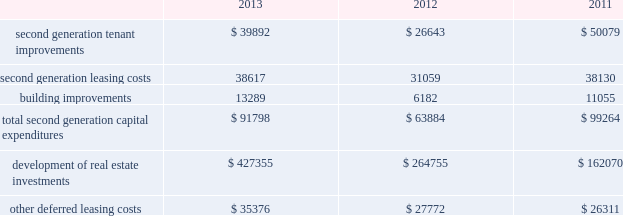36 duke realty corporation annual report 2013 leasing/capital costs tenant improvements and lease-related costs pertaining to our initial leasing of newly completed space , or vacant space in acquired properties , are referred to as first generation expenditures .
Such first generation expenditures for tenant improvements are included within "development of real estate investments" in our consolidated statements of cash flows , while such expenditures for lease-related costs are included within "other deferred leasing costs." cash expenditures related to the construction of a building's shell , as well as the associated site improvements , are also included within "development of real estate investments" in our consolidated statements of cash flows .
Tenant improvements and leasing costs to re-let rental space that we previously leased to tenants are referred to as second generation expenditures .
Building improvements that are not specific to any tenant but serve to improve integral components of our real estate properties are also second generation expenditures .
One of our principal uses of our liquidity is to fund the second generation leasing/capital expenditures of our real estate investments .
The table summarizes our second generation capital expenditures by type of expenditure ( in thousands ) : .
Second generation tenant improvements and leasing costs increased due to a shift in industrial leasing volume from renewal leases to second generation leases ( see data in the key performance indicators section of management's discussion and analysis of financial condition and results of operations ) , which are generally more capital intensive .
Additionally , although the overall renewal volume was lower , renewals for office leases , which are generally more capital intensive than industrial leases , increased from 2012 .
During 2013 , we increased our investment across all product types in non-tenant specific building improvements .
The increase in capital expenditures for the development of real estate investments was the result of our increased focus on wholly owned development projects .
We had wholly owned properties under development with an expected cost of $ 572.6 million at december 31 , 2013 , compared to projects with an expected cost of $ 468.8 million and $ 124.2 million at december 31 , 2012 and 2011 , respectively .
Cash outflows for real estate development investments were $ 427.4 million , $ 264.8 million and $ 162.1 million for december 31 , 2013 , 2012 and 2011 , respectively .
We capitalized $ 31.3 million , $ 30.4 million and $ 25.3 million of overhead costs related to leasing activities , including both first and second generation leases , during the years ended december 31 , 2013 , 2012 and 2011 , respectively .
We capitalized $ 27.1 million , $ 20.0 million and $ 10.4 million of overhead costs related to development activities , including construction , development and tenant improvement projects on first and second generation space , during the years ended december 31 , 2013 , 2012 and 2011 , respectively .
Combined overhead costs capitalized to leasing and development totaled 35.7% ( 35.7 % ) , 31.1% ( 31.1 % ) and 20.6% ( 20.6 % ) of our overall pool of overhead costs at december 31 , 2013 , 2012 and 2011 , respectively .
Further discussion of the capitalization of overhead costs can be found herein , in the discussion of general and administrative expenses in the comparison sections of management's discussion and analysis of financial condition and results of operations. .
What was the percentage change in the second generation tenant improvements from 2012 to 2013? 
Computations: ((39892 - 26643) / 26643)
Answer: 0.49728. 